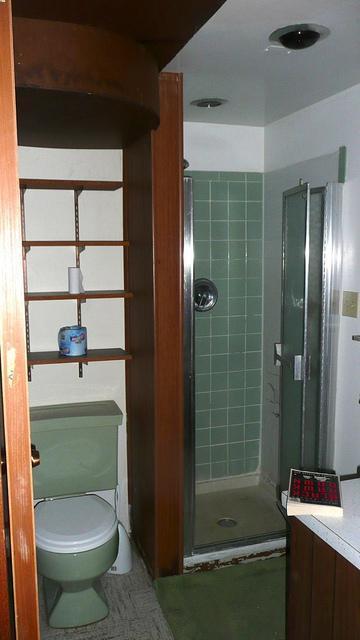How many rolls of toilet paper are on the shelves above the toilet?
Give a very brief answer. 2. How many people are using a desktop computer?
Give a very brief answer. 0. 